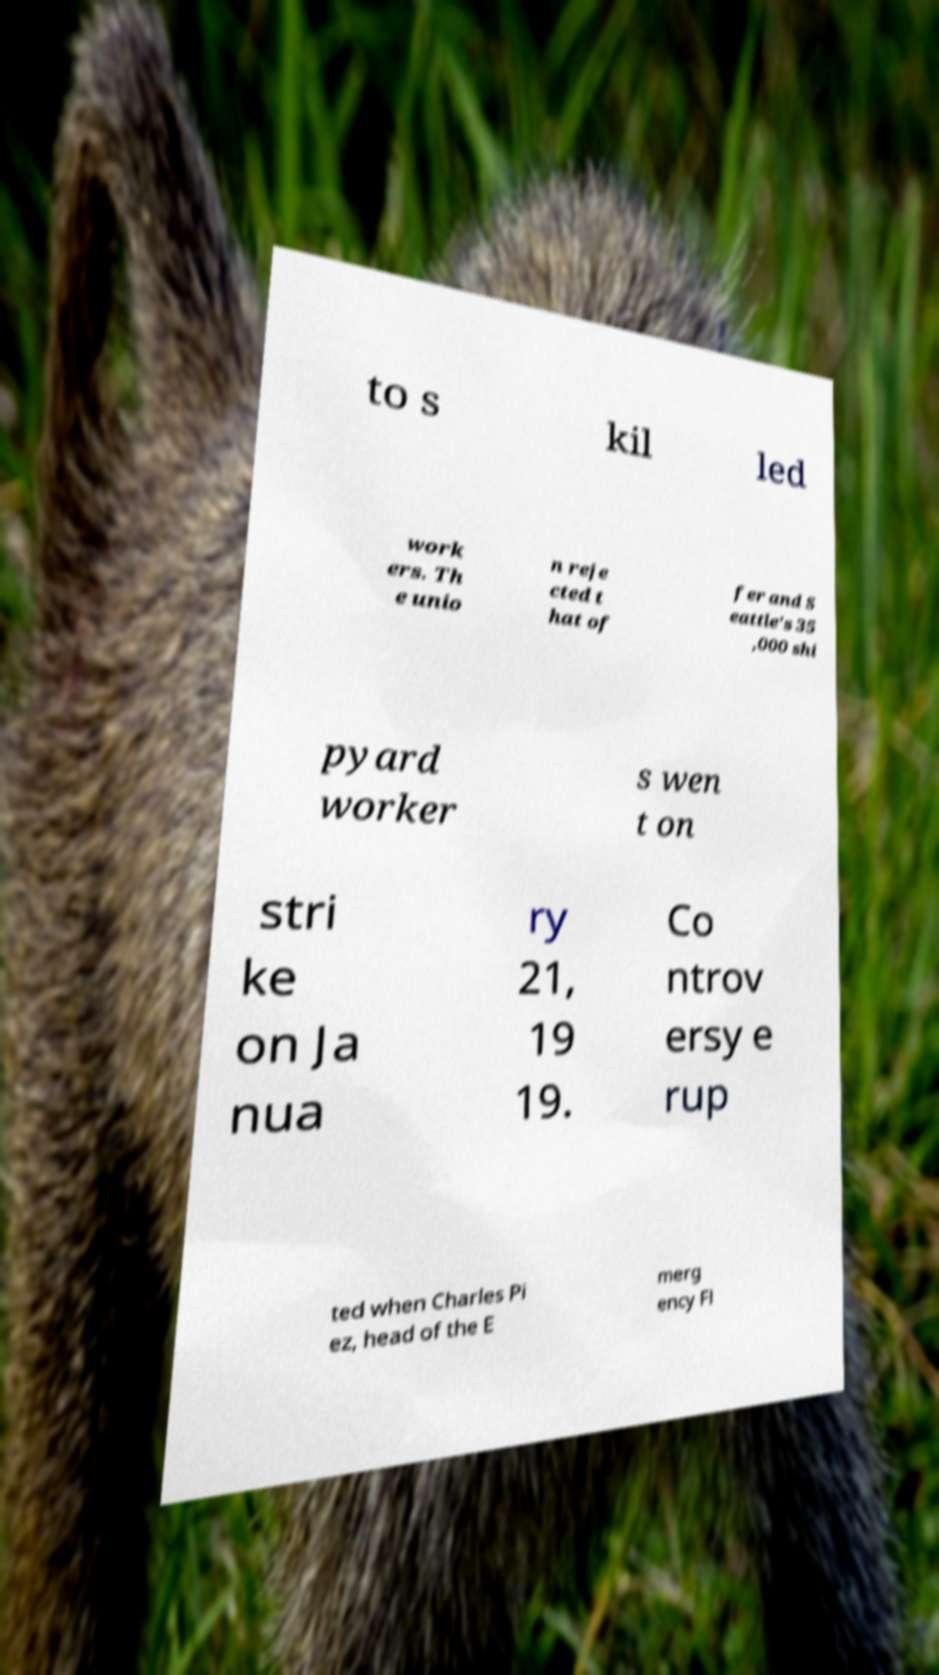Please identify and transcribe the text found in this image. to s kil led work ers. Th e unio n reje cted t hat of fer and S eattle's 35 ,000 shi pyard worker s wen t on stri ke on Ja nua ry 21, 19 19. Co ntrov ersy e rup ted when Charles Pi ez, head of the E merg ency Fl 